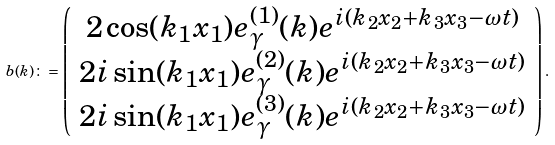Convert formula to latex. <formula><loc_0><loc_0><loc_500><loc_500>b ( k ) \colon = \left ( \begin{array} { c } 2 \cos ( k _ { 1 } x _ { 1 } ) e ^ { ( 1 ) } _ { \gamma } ( k ) e ^ { i ( k _ { 2 } x _ { 2 } + k _ { 3 } x _ { 3 } - \omega t ) } \\ 2 i \sin ( k _ { 1 } x _ { 1 } ) e ^ { ( 2 ) } _ { \gamma } ( k ) e ^ { i ( k _ { 2 } x _ { 2 } + k _ { 3 } x _ { 3 } - \omega t ) } \\ 2 i \sin ( k _ { 1 } x _ { 1 } ) e ^ { ( 3 ) } _ { \gamma } ( k ) e ^ { i ( k _ { 2 } x _ { 2 } + k _ { 3 } x _ { 3 } - \omega t ) } \end{array} \right ) .</formula> 